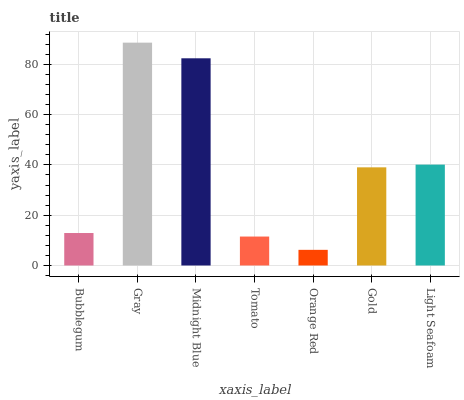Is Orange Red the minimum?
Answer yes or no. Yes. Is Gray the maximum?
Answer yes or no. Yes. Is Midnight Blue the minimum?
Answer yes or no. No. Is Midnight Blue the maximum?
Answer yes or no. No. Is Gray greater than Midnight Blue?
Answer yes or no. Yes. Is Midnight Blue less than Gray?
Answer yes or no. Yes. Is Midnight Blue greater than Gray?
Answer yes or no. No. Is Gray less than Midnight Blue?
Answer yes or no. No. Is Gold the high median?
Answer yes or no. Yes. Is Gold the low median?
Answer yes or no. Yes. Is Bubblegum the high median?
Answer yes or no. No. Is Tomato the low median?
Answer yes or no. No. 